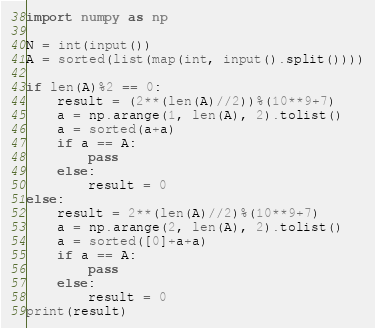Convert code to text. <code><loc_0><loc_0><loc_500><loc_500><_Python_>import numpy as np

N = int(input())
A = sorted(list(map(int, input().split())))

if len(A)%2 == 0:
    result = (2**(len(A)//2))%(10**9+7)
    a = np.arange(1, len(A), 2).tolist()
    a = sorted(a+a)
    if a == A:
        pass
    else:
        result = 0
else:
    result = 2**(len(A)//2)%(10**9+7)
    a = np.arange(2, len(A), 2).tolist()
    a = sorted([0]+a+a)
    if a == A:
        pass
    else:
        result = 0
print(result)</code> 